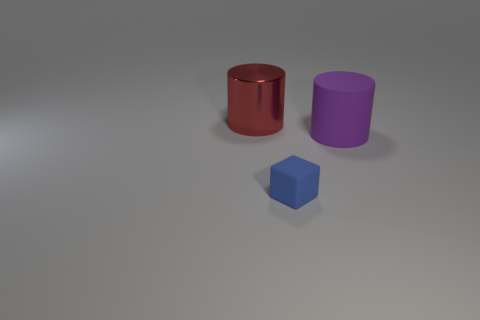Is there any other thing that is the same size as the block?
Provide a succinct answer. No. There is a thing that is on the right side of the tiny blue object; how big is it?
Ensure brevity in your answer.  Large. There is a large object that is on the right side of the metal object behind the purple matte cylinder; what number of blue rubber cubes are to the left of it?
Give a very brief answer. 1. What is the color of the large cylinder that is behind the large object in front of the red metal cylinder?
Provide a succinct answer. Red. Is there a red thing of the same size as the matte cylinder?
Your answer should be very brief. Yes. There is a large thing behind the large object that is in front of the large cylinder behind the purple thing; what is it made of?
Offer a terse response. Metal. There is a cylinder that is in front of the red cylinder; what number of big things are behind it?
Offer a very short reply. 1. There is a thing that is behind the rubber cylinder; is its size the same as the purple thing?
Provide a short and direct response. Yes. What number of other red objects have the same shape as the large red metallic object?
Keep it short and to the point. 0. What is the shape of the large red object?
Make the answer very short. Cylinder. 